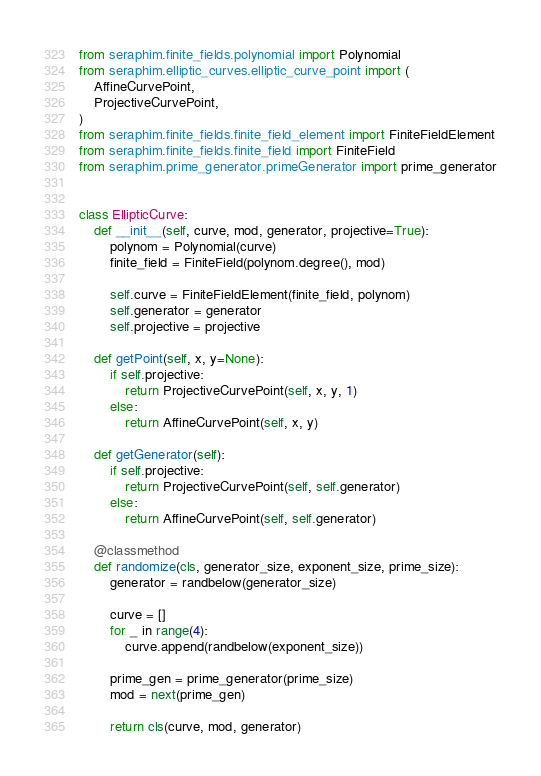Convert code to text. <code><loc_0><loc_0><loc_500><loc_500><_Python_>from seraphim.finite_fields.polynomial import Polynomial
from seraphim.elliptic_curves.elliptic_curve_point import (
    AffineCurvePoint,
    ProjectiveCurvePoint,
)
from seraphim.finite_fields.finite_field_element import FiniteFieldElement
from seraphim.finite_fields.finite_field import FiniteField
from seraphim.prime_generator.primeGenerator import prime_generator


class EllipticCurve:
    def __init__(self, curve, mod, generator, projective=True):
        polynom = Polynomial(curve)
        finite_field = FiniteField(polynom.degree(), mod)

        self.curve = FiniteFieldElement(finite_field, polynom)
        self.generator = generator
        self.projective = projective

    def getPoint(self, x, y=None):
        if self.projective:
            return ProjectiveCurvePoint(self, x, y, 1)
        else:
            return AffineCurvePoint(self, x, y)

    def getGenerator(self):
        if self.projective:
            return ProjectiveCurvePoint(self, self.generator)
        else:
            return AffineCurvePoint(self, self.generator)

    @classmethod
    def randomize(cls, generator_size, exponent_size, prime_size):
        generator = randbelow(generator_size)

        curve = []
        for _ in range(4):
            curve.append(randbelow(exponent_size))

        prime_gen = prime_generator(prime_size)
        mod = next(prime_gen)

        return cls(curve, mod, generator)
</code> 